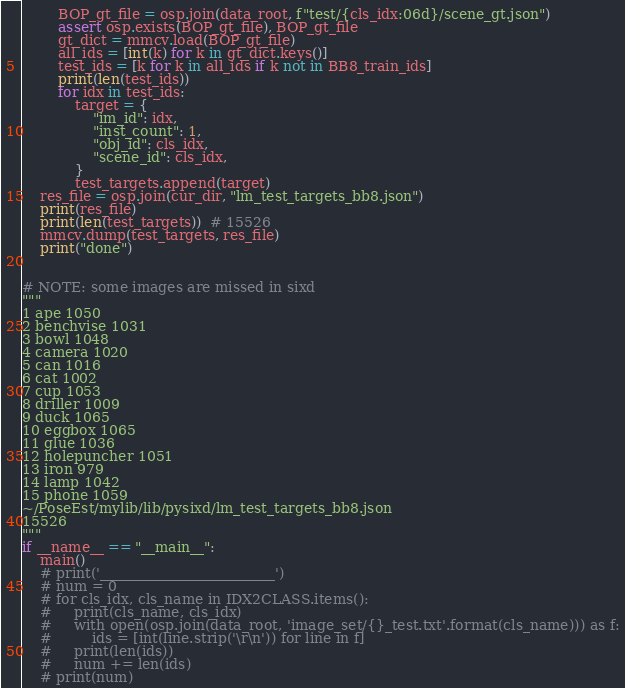<code> <loc_0><loc_0><loc_500><loc_500><_Python_>        BOP_gt_file = osp.join(data_root, f"test/{cls_idx:06d}/scene_gt.json")
        assert osp.exists(BOP_gt_file), BOP_gt_file
        gt_dict = mmcv.load(BOP_gt_file)
        all_ids = [int(k) for k in gt_dict.keys()]
        test_ids = [k for k in all_ids if k not in BB8_train_ids]
        print(len(test_ids))
        for idx in test_ids:
            target = {
                "im_id": idx,
                "inst_count": 1,
                "obj_id": cls_idx,
                "scene_id": cls_idx,
            }
            test_targets.append(target)
    res_file = osp.join(cur_dir, "lm_test_targets_bb8.json")
    print(res_file)
    print(len(test_targets))  # 15526
    mmcv.dump(test_targets, res_file)
    print("done")


# NOTE: some images are missed in sixd
"""
1 ape 1050
2 benchvise 1031
3 bowl 1048
4 camera 1020
5 can 1016
6 cat 1002
7 cup 1053
8 driller 1009
9 duck 1065
10 eggbox 1065
11 glue 1036
12 holepuncher 1051
13 iron 979
14 lamp 1042
15 phone 1059
~/PoseEst/mylib/lib/pysixd/lm_test_targets_bb8.json
15526
"""
if __name__ == "__main__":
    main()
    # print('_________________________')
    # num = 0
    # for cls_idx, cls_name in IDX2CLASS.items():
    #     print(cls_name, cls_idx)
    #     with open(osp.join(data_root, 'image_set/{}_test.txt'.format(cls_name))) as f:
    #         ids = [int(line.strip('\r\n')) for line in f]
    #     print(len(ids))
    #     num += len(ids)
    # print(num)
</code> 